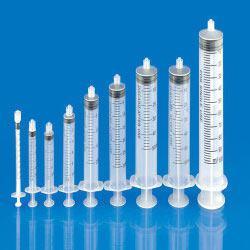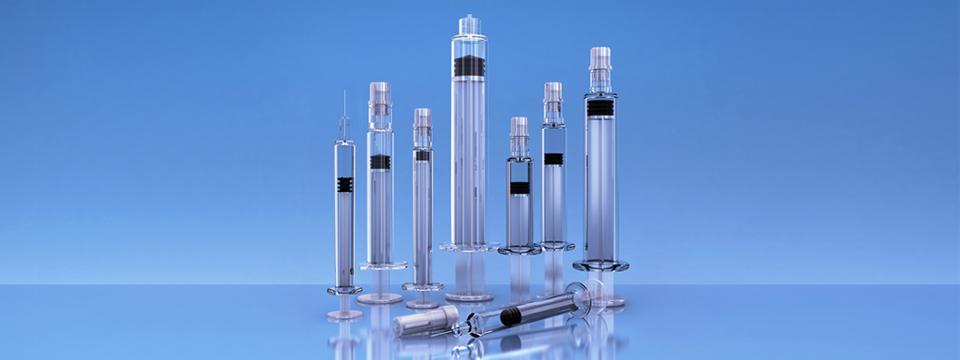The first image is the image on the left, the second image is the image on the right. Examine the images to the left and right. Is the description "There are seven syringes." accurate? Answer yes or no. No. 